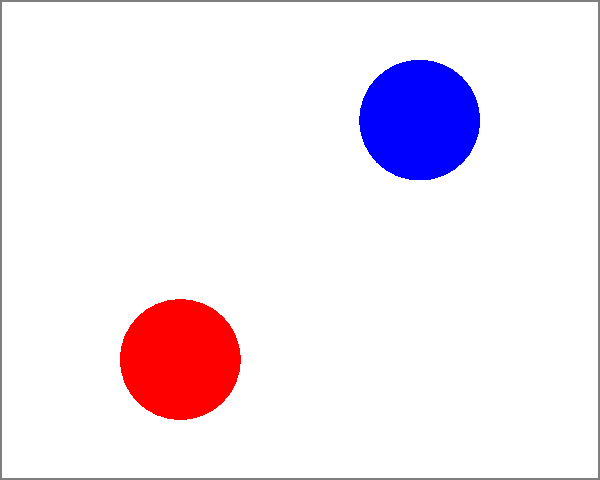In a Holocaust memorial painting, four key elements (A, B, C, and D) are arranged as shown. Which element should be moved to achieve better compositional balance around the central axis? To achieve compositional balance in a painting, we need to consider the visual weight of elements on both sides of the central axis. Let's analyze the current arrangement:

1. The canvas is divided into two equal halves by the dashed line, representing the central axis.

2. On the left side:
   - Element A: red circle, lower left
   - Element C: green rectangle, upper left

3. On the right side:
   - Element B: blue circle, upper right
   - Element D: yellow rectangle, lower right

4. Visual weight considerations:
   - Size: All elements appear to have similar sizes
   - Color: Warm colors (red, yellow) tend to have more visual weight than cool colors (blue, green)
   - Position: Elements closer to the edges tend to have more visual weight

5. Current balance assessment:
   - Left side: A (red, lower) + C (green, upper)
   - Right side: B (blue, upper) + D (yellow, lower)

6. The right side appears slightly heavier due to the warm yellow color of element D in the lower right corner.

7. To achieve better balance, we should move one element to counteract this imbalance.

8. The most effective solution would be to move element C (green rectangle) from the upper left to the lower right, swapping positions with element D (yellow rectangle).

This adjustment would:
- Bring a cooler color (green) to the right side, reducing its overall visual weight
- Move a warmer color (yellow) to the left side, increasing its visual weight
- Maintain the diagonal relationship between elements
Answer: Element C 